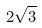<formula> <loc_0><loc_0><loc_500><loc_500>2 \sqrt { 3 }</formula> 